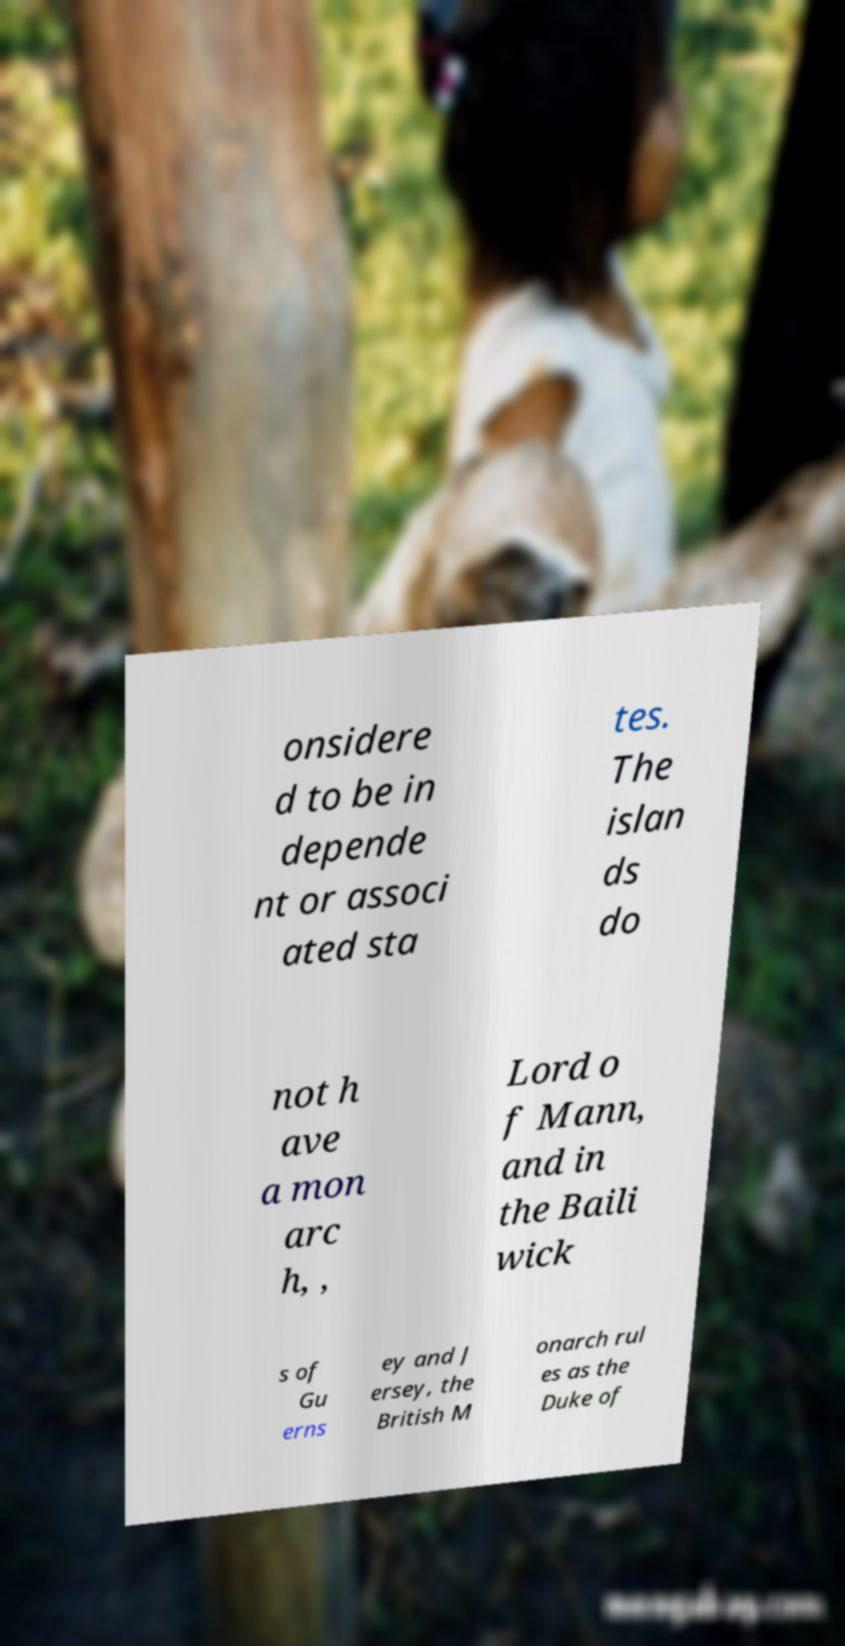Please identify and transcribe the text found in this image. onsidere d to be in depende nt or associ ated sta tes. The islan ds do not h ave a mon arc h, , Lord o f Mann, and in the Baili wick s of Gu erns ey and J ersey, the British M onarch rul es as the Duke of 